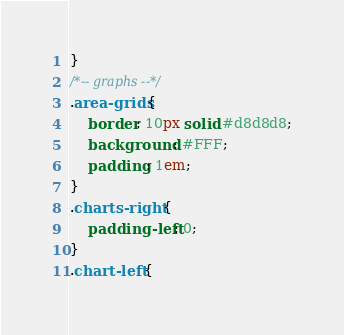Convert code to text. <code><loc_0><loc_0><loc_500><loc_500><_CSS_>}
/*-- graphs --*/
.area-grids{
    border: 10px solid #d8d8d8;
    background: #FFF;
    padding: 1em;
}
.charts-right {
    padding-left: 0;
}
.chart-left {</code> 